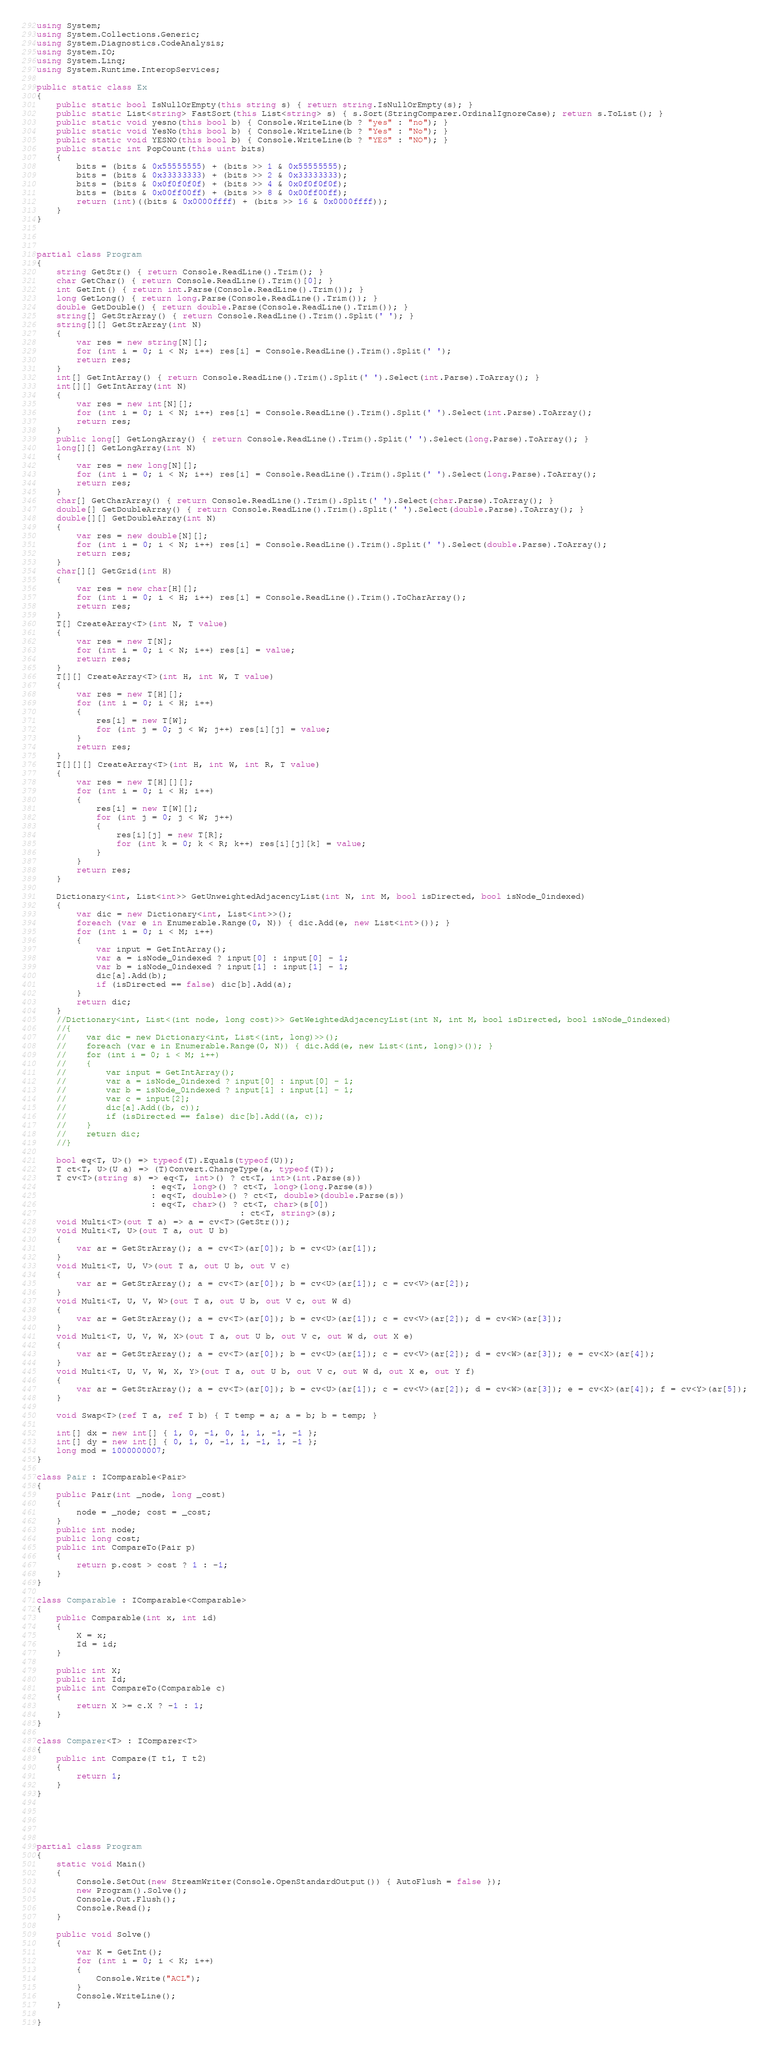<code> <loc_0><loc_0><loc_500><loc_500><_C#_>using System;
using System.Collections.Generic;
using System.Diagnostics.CodeAnalysis;
using System.IO;
using System.Linq;
using System.Runtime.InteropServices;

public static class Ex
{
    public static bool IsNullOrEmpty(this string s) { return string.IsNullOrEmpty(s); }
    public static List<string> FastSort(this List<string> s) { s.Sort(StringComparer.OrdinalIgnoreCase); return s.ToList(); }
    public static void yesno(this bool b) { Console.WriteLine(b ? "yes" : "no"); }
    public static void YesNo(this bool b) { Console.WriteLine(b ? "Yes" : "No"); }
    public static void YESNO(this bool b) { Console.WriteLine(b ? "YES" : "NO"); }
    public static int PopCount(this uint bits)
    {
        bits = (bits & 0x55555555) + (bits >> 1 & 0x55555555);
        bits = (bits & 0x33333333) + (bits >> 2 & 0x33333333);
        bits = (bits & 0x0f0f0f0f) + (bits >> 4 & 0x0f0f0f0f);
        bits = (bits & 0x00ff00ff) + (bits >> 8 & 0x00ff00ff);
        return (int)((bits & 0x0000ffff) + (bits >> 16 & 0x0000ffff));
    }
}



partial class Program
{
    string GetStr() { return Console.ReadLine().Trim(); }
    char GetChar() { return Console.ReadLine().Trim()[0]; }
    int GetInt() { return int.Parse(Console.ReadLine().Trim()); }
    long GetLong() { return long.Parse(Console.ReadLine().Trim()); }
    double GetDouble() { return double.Parse(Console.ReadLine().Trim()); }
    string[] GetStrArray() { return Console.ReadLine().Trim().Split(' '); }
    string[][] GetStrArray(int N)
    {
        var res = new string[N][];
        for (int i = 0; i < N; i++) res[i] = Console.ReadLine().Trim().Split(' ');
        return res;
    }
    int[] GetIntArray() { return Console.ReadLine().Trim().Split(' ').Select(int.Parse).ToArray(); }
    int[][] GetIntArray(int N)
    {
        var res = new int[N][];
        for (int i = 0; i < N; i++) res[i] = Console.ReadLine().Trim().Split(' ').Select(int.Parse).ToArray();
        return res;
    }
    public long[] GetLongArray() { return Console.ReadLine().Trim().Split(' ').Select(long.Parse).ToArray(); }
    long[][] GetLongArray(int N)
    {
        var res = new long[N][];
        for (int i = 0; i < N; i++) res[i] = Console.ReadLine().Trim().Split(' ').Select(long.Parse).ToArray();
        return res;
    }
    char[] GetCharArray() { return Console.ReadLine().Trim().Split(' ').Select(char.Parse).ToArray(); }
    double[] GetDoubleArray() { return Console.ReadLine().Trim().Split(' ').Select(double.Parse).ToArray(); }
    double[][] GetDoubleArray(int N)
    {
        var res = new double[N][];
        for (int i = 0; i < N; i++) res[i] = Console.ReadLine().Trim().Split(' ').Select(double.Parse).ToArray();
        return res;
    }
    char[][] GetGrid(int H)
    {
        var res = new char[H][];
        for (int i = 0; i < H; i++) res[i] = Console.ReadLine().Trim().ToCharArray();
        return res;
    }
    T[] CreateArray<T>(int N, T value)
    {
        var res = new T[N];
        for (int i = 0; i < N; i++) res[i] = value;
        return res;
    }
    T[][] CreateArray<T>(int H, int W, T value)
    {
        var res = new T[H][];
        for (int i = 0; i < H; i++)
        {
            res[i] = new T[W];
            for (int j = 0; j < W; j++) res[i][j] = value;
        }
        return res;
    }
    T[][][] CreateArray<T>(int H, int W, int R, T value)
    {
        var res = new T[H][][];
        for (int i = 0; i < H; i++)
        {
            res[i] = new T[W][];
            for (int j = 0; j < W; j++)
            {
                res[i][j] = new T[R];
                for (int k = 0; k < R; k++) res[i][j][k] = value;
            }
        }
        return res;
    }

    Dictionary<int, List<int>> GetUnweightedAdjacencyList(int N, int M, bool isDirected, bool isNode_0indexed)
    {
        var dic = new Dictionary<int, List<int>>();
        foreach (var e in Enumerable.Range(0, N)) { dic.Add(e, new List<int>()); }
        for (int i = 0; i < M; i++)
        {
            var input = GetIntArray();
            var a = isNode_0indexed ? input[0] : input[0] - 1;
            var b = isNode_0indexed ? input[1] : input[1] - 1;
            dic[a].Add(b);
            if (isDirected == false) dic[b].Add(a);
        }
        return dic;
    }
    //Dictionary<int, List<(int node, long cost)>> GetWeightedAdjacencyList(int N, int M, bool isDirected, bool isNode_0indexed)
    //{
    //    var dic = new Dictionary<int, List<(int, long)>>();
    //    foreach (var e in Enumerable.Range(0, N)) { dic.Add(e, new List<(int, long)>()); }
    //    for (int i = 0; i < M; i++)
    //    {
    //        var input = GetIntArray();
    //        var a = isNode_0indexed ? input[0] : input[0] - 1;
    //        var b = isNode_0indexed ? input[1] : input[1] - 1;
    //        var c = input[2];
    //        dic[a].Add((b, c));
    //        if (isDirected == false) dic[b].Add((a, c));
    //    }
    //    return dic;
    //}

    bool eq<T, U>() => typeof(T).Equals(typeof(U));
    T ct<T, U>(U a) => (T)Convert.ChangeType(a, typeof(T));
    T cv<T>(string s) => eq<T, int>() ? ct<T, int>(int.Parse(s))
                       : eq<T, long>() ? ct<T, long>(long.Parse(s))
                       : eq<T, double>() ? ct<T, double>(double.Parse(s))
                       : eq<T, char>() ? ct<T, char>(s[0])
                                         : ct<T, string>(s);
    void Multi<T>(out T a) => a = cv<T>(GetStr());
    void Multi<T, U>(out T a, out U b)
    {
        var ar = GetStrArray(); a = cv<T>(ar[0]); b = cv<U>(ar[1]);
    }
    void Multi<T, U, V>(out T a, out U b, out V c)
    {
        var ar = GetStrArray(); a = cv<T>(ar[0]); b = cv<U>(ar[1]); c = cv<V>(ar[2]);
    }
    void Multi<T, U, V, W>(out T a, out U b, out V c, out W d)
    {
        var ar = GetStrArray(); a = cv<T>(ar[0]); b = cv<U>(ar[1]); c = cv<V>(ar[2]); d = cv<W>(ar[3]);
    }
    void Multi<T, U, V, W, X>(out T a, out U b, out V c, out W d, out X e)
    {
        var ar = GetStrArray(); a = cv<T>(ar[0]); b = cv<U>(ar[1]); c = cv<V>(ar[2]); d = cv<W>(ar[3]); e = cv<X>(ar[4]);
    }
    void Multi<T, U, V, W, X, Y>(out T a, out U b, out V c, out W d, out X e, out Y f)
    {
        var ar = GetStrArray(); a = cv<T>(ar[0]); b = cv<U>(ar[1]); c = cv<V>(ar[2]); d = cv<W>(ar[3]); e = cv<X>(ar[4]); f = cv<Y>(ar[5]);
    }

    void Swap<T>(ref T a, ref T b) { T temp = a; a = b; b = temp; }

    int[] dx = new int[] { 1, 0, -1, 0, 1, 1, -1, -1 };
    int[] dy = new int[] { 0, 1, 0, -1, 1, -1, 1, -1 };
    long mod = 1000000007;
}

class Pair : IComparable<Pair>
{
    public Pair(int _node, long _cost)
    {
        node = _node; cost = _cost;
    }
    public int node;
    public long cost;
    public int CompareTo(Pair p)
    {
        return p.cost > cost ? 1 : -1;
    }
}

class Comparable : IComparable<Comparable>
{
    public Comparable(int x, int id)
    {
        X = x;
        Id = id;
    }

    public int X;
    public int Id;
    public int CompareTo(Comparable c)
    {
        return X >= c.X ? -1 : 1;
    }
}

class Comparer<T> : IComparer<T>
{
    public int Compare(T t1, T t2)
    {
        return 1;
    }
}





partial class Program
{
    static void Main()
    {
        Console.SetOut(new StreamWriter(Console.OpenStandardOutput()) { AutoFlush = false });
        new Program().Solve();
        Console.Out.Flush();
        Console.Read();
    }

    public void Solve()
    {
        var K = GetInt();
        for (int i = 0; i < K; i++)
        {
            Console.Write("ACL");
        }
        Console.WriteLine();
    }

}
</code> 